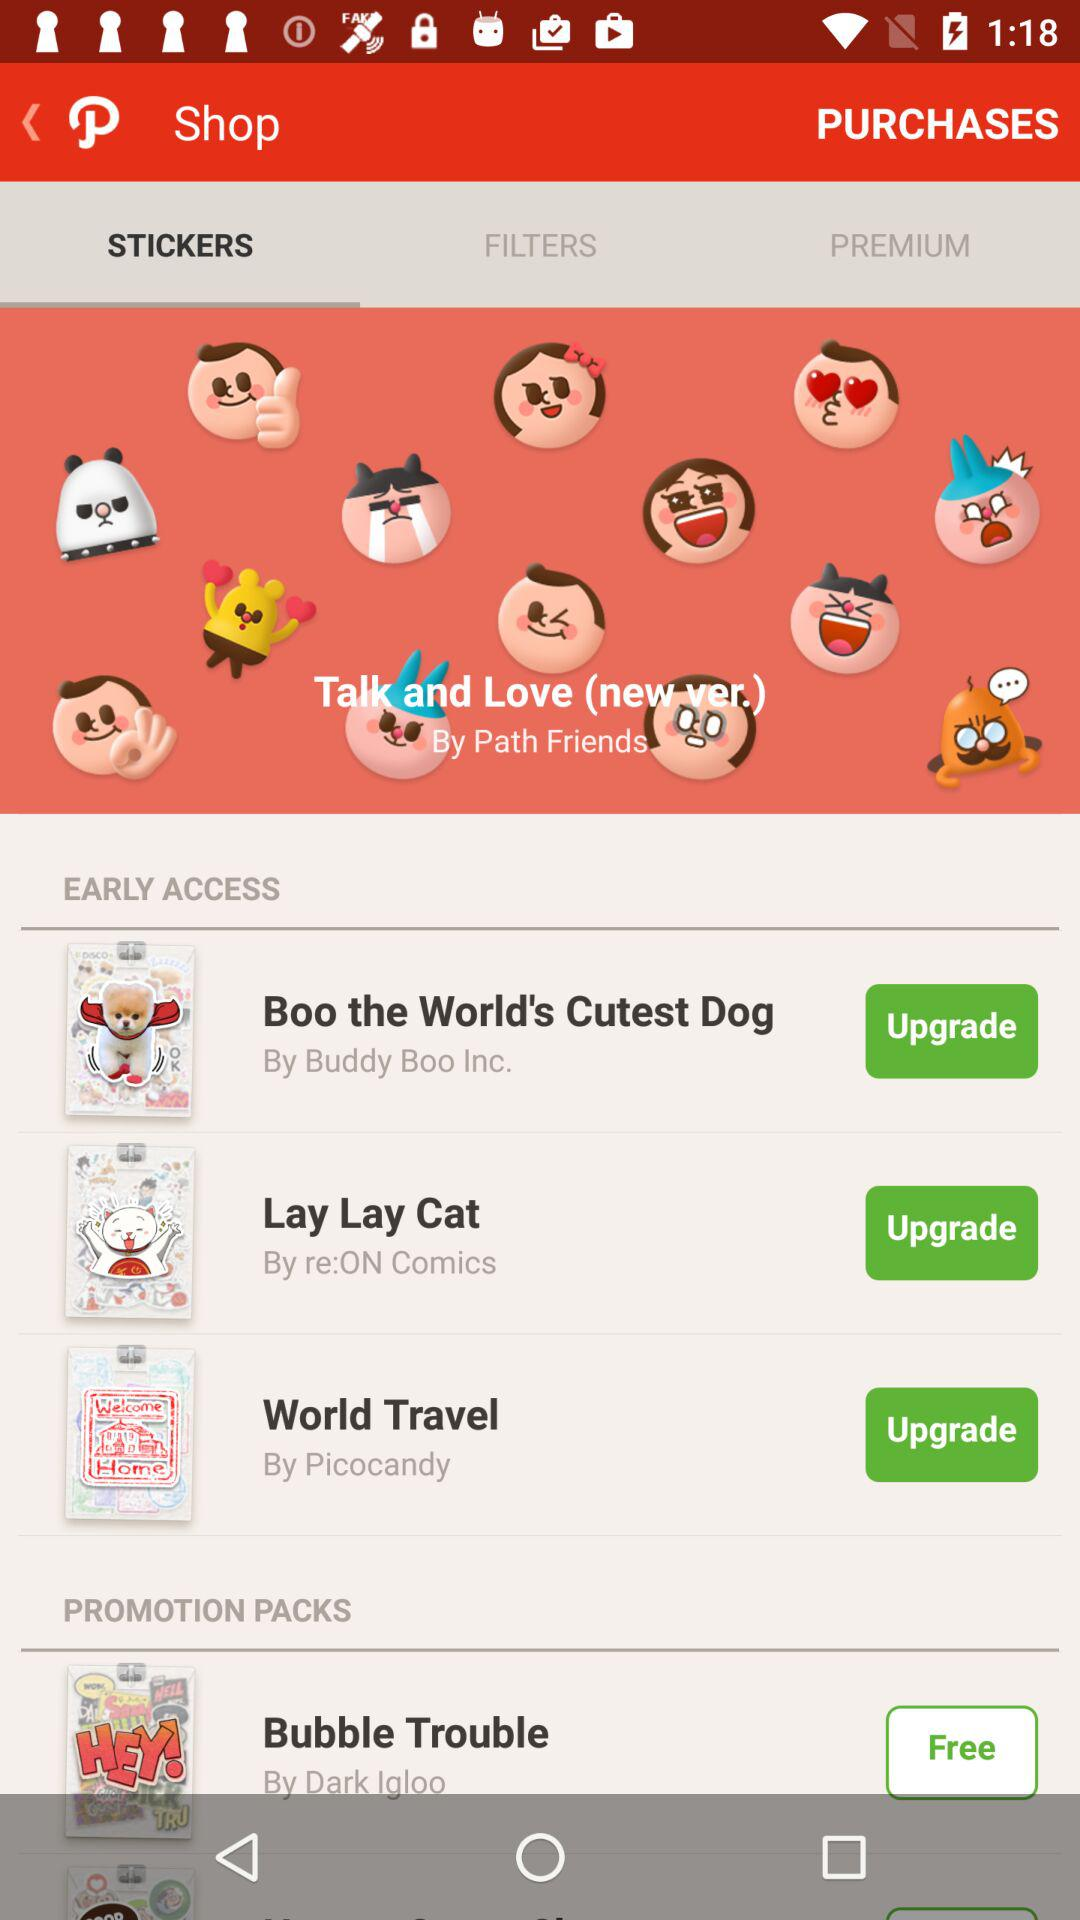What's the price of the "Bubble Trouble" pack? The "Bubble Trouble" pack is free. 